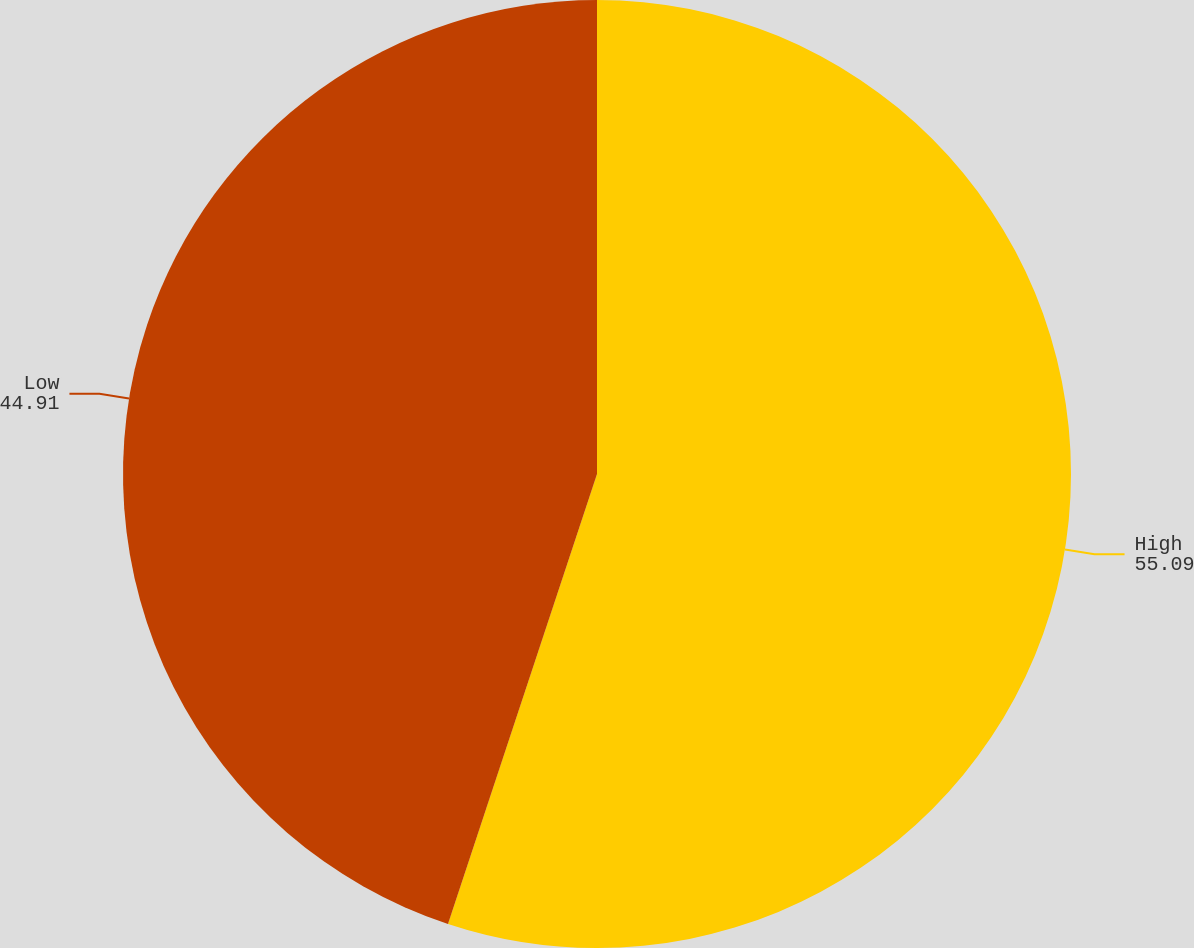Convert chart. <chart><loc_0><loc_0><loc_500><loc_500><pie_chart><fcel>High<fcel>Low<nl><fcel>55.09%<fcel>44.91%<nl></chart> 